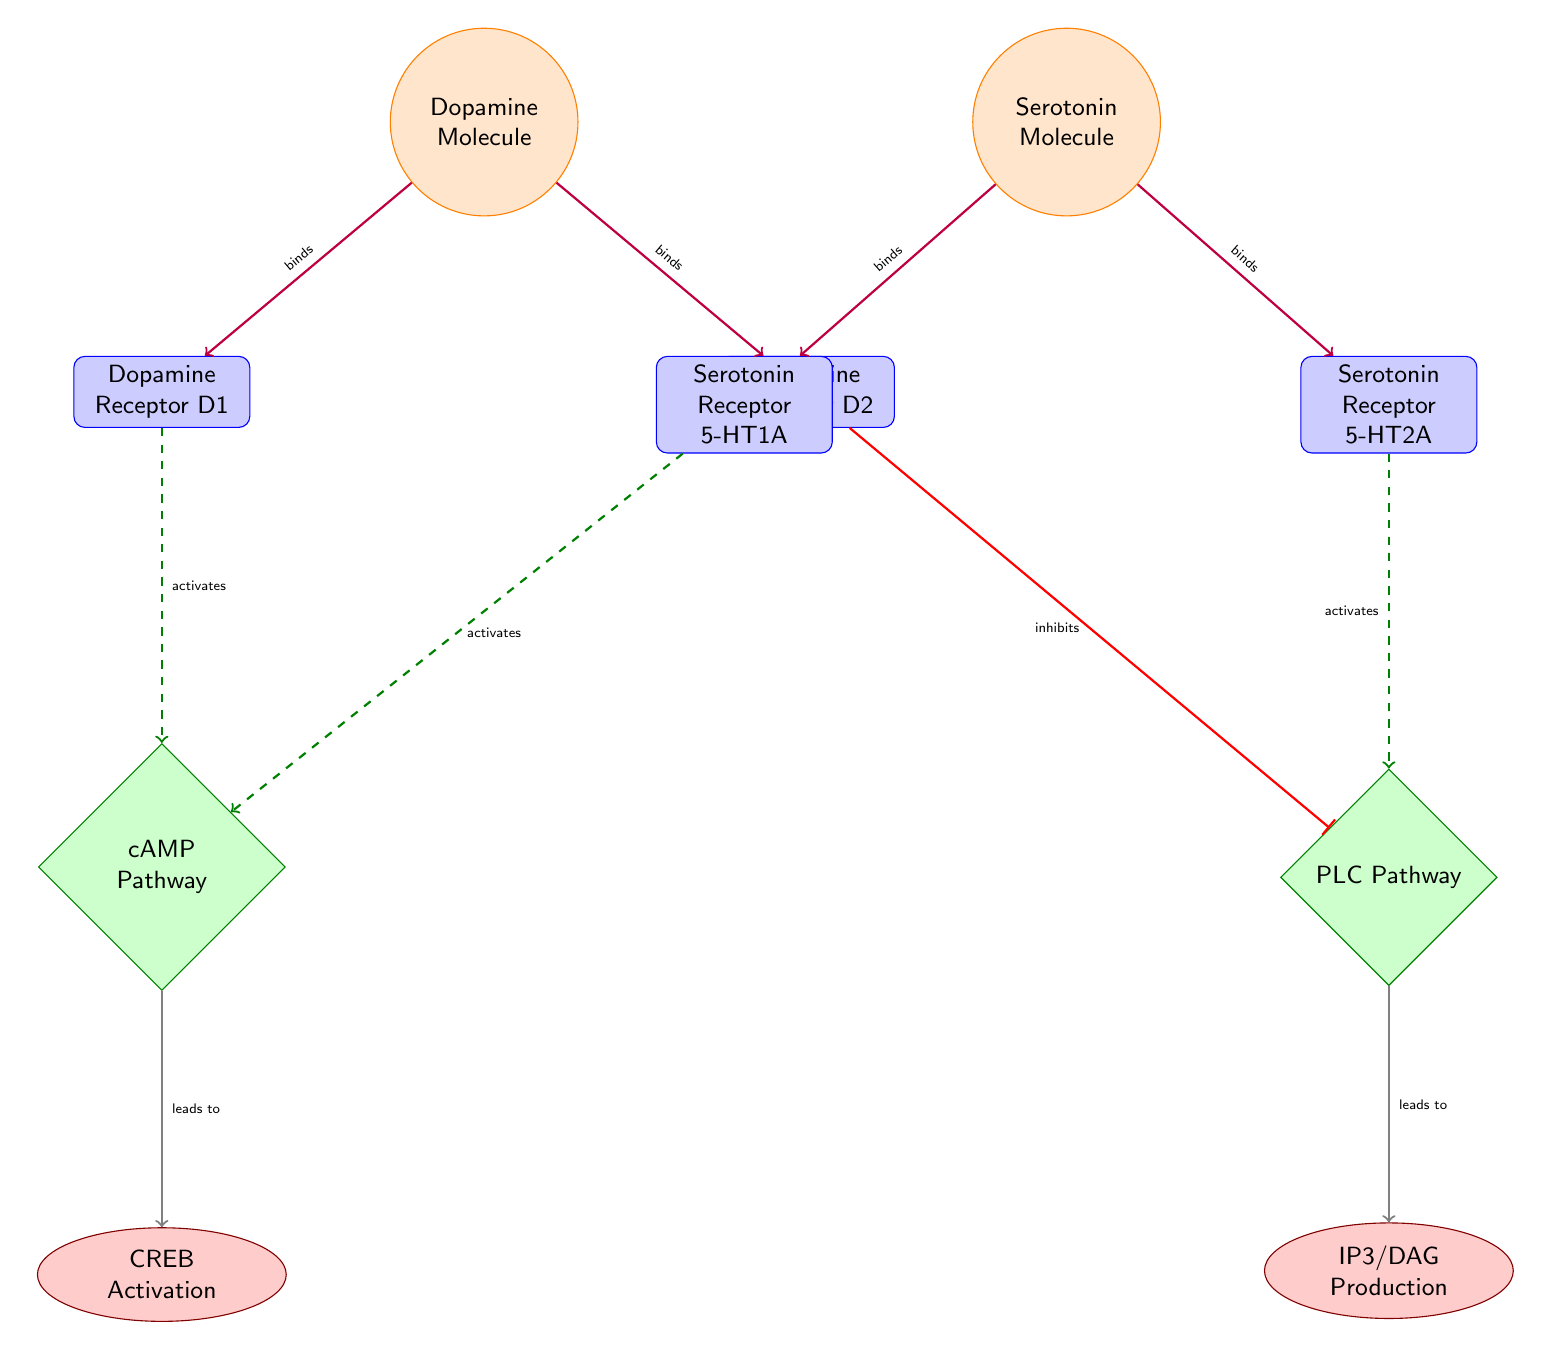What molecules interact with the Dopamine Receptors? The diagram indicates that both the Dopamine Molecule binds to Dopamine Receptor D1 and Dopamine Receptor D2.
Answer: Dopamine Molecule What inhibits the PLC Pathway? Looking at the diagram, the Dopamine Receptor D2 inhibits the PLC Pathway.
Answer: Dopamine Receptor D2 How many pathways are represented in the diagram? The diagram shows two pathways: the cAMP Pathway and the PLC Pathway, thus there are two pathways.
Answer: 2 What is the output of the cAMP Pathway? The cAMP Pathway leads to the CREB Activation process as indicated in the diagram.
Answer: CREB Activation Which neurotransmitter has two receptors shown in the diagram? The Serotonin Molecule has two receptors, Serotonin Receptor 5-HT1A and Serotonin Receptor 5-HT2A.
Answer: Serotonin Molecule What does the activation of Serotonin Receptor 5-HT1A lead to? Following the diagram flow, activating the Serotonin Receptor 5-HT1A activates the cAMP Pathway, which leads to CREB Activation.
Answer: CREB Activation What type of connection does the Dopamine Molecule have with its receptors? The connections from the Dopamine Molecule to both its receptors (Dopamine Receptor D1 and D2) are binding types.
Answer: binds What process is associated with the PLC Pathway? The diagram shows that the PLC Pathway leads to the production of IP3/DAG.
Answer: IP3/DAG Production What color represents the neurotransmitter molecules in the diagram? The neurotransmitter molecules are represented in orange, as per the style settings in the diagram.
Answer: Orange 